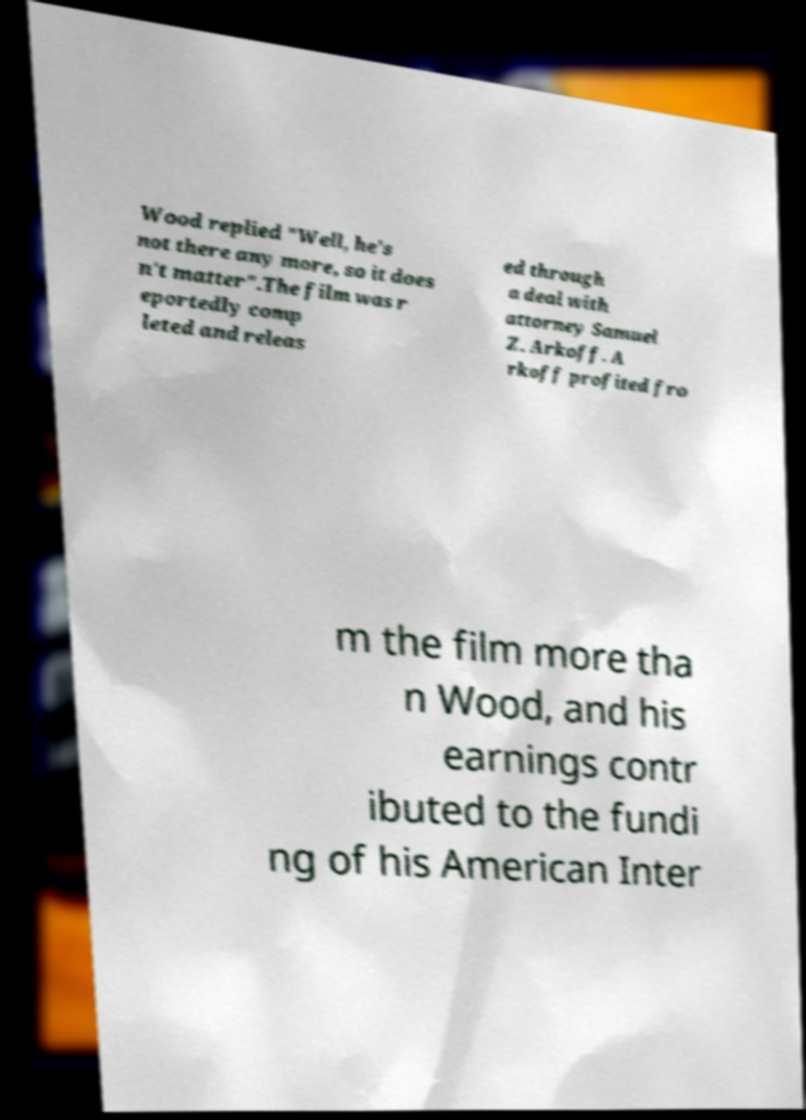What messages or text are displayed in this image? I need them in a readable, typed format. Wood replied "Well, he's not there any more, so it does n't matter".The film was r eportedly comp leted and releas ed through a deal with attorney Samuel Z. Arkoff. A rkoff profited fro m the film more tha n Wood, and his earnings contr ibuted to the fundi ng of his American Inter 